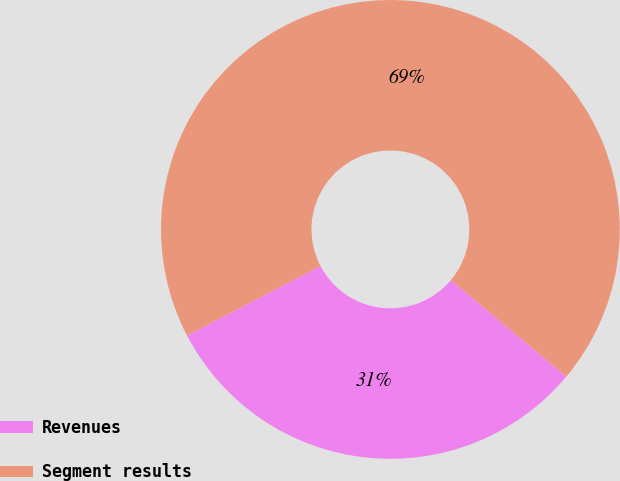Convert chart. <chart><loc_0><loc_0><loc_500><loc_500><pie_chart><fcel>Revenues<fcel>Segment results<nl><fcel>31.25%<fcel>68.75%<nl></chart> 